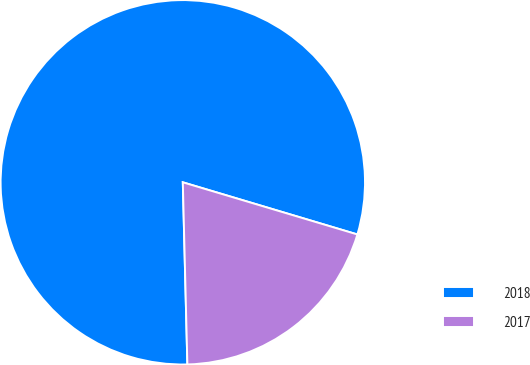<chart> <loc_0><loc_0><loc_500><loc_500><pie_chart><fcel>2018<fcel>2017<nl><fcel>80.02%<fcel>19.98%<nl></chart> 